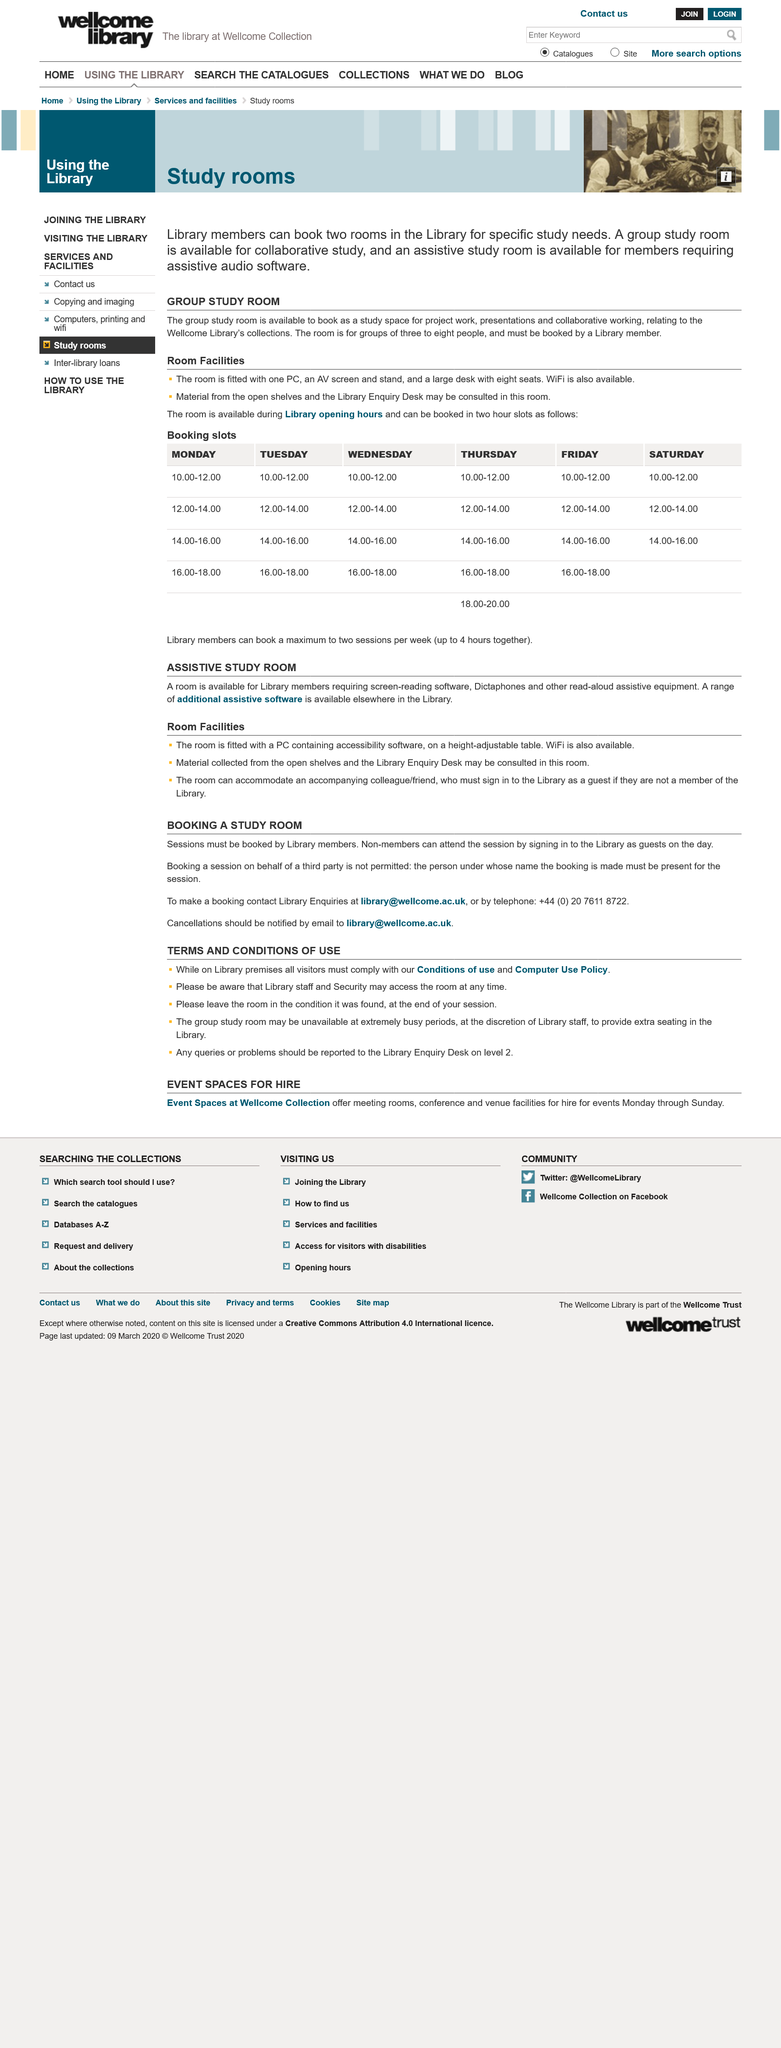Highlight a few significant elements in this photo. The group study room is used for collaborative study. The assistive study room is a specialized facility made available to library members who require screen-reading software, dictaphones, and other assistive equipment to facilitate their studies. This room is designed to provide a comfortable and accessible environment for individuals with disabilities to conduct their research and academic pursuits. The Library Enquiry Desk is located on level 2. The group study room can accommodate 3 to 8 people, depending on the specific configuration of the space. To utilize the library, five (5) terms and conditions must be followed as listed. 